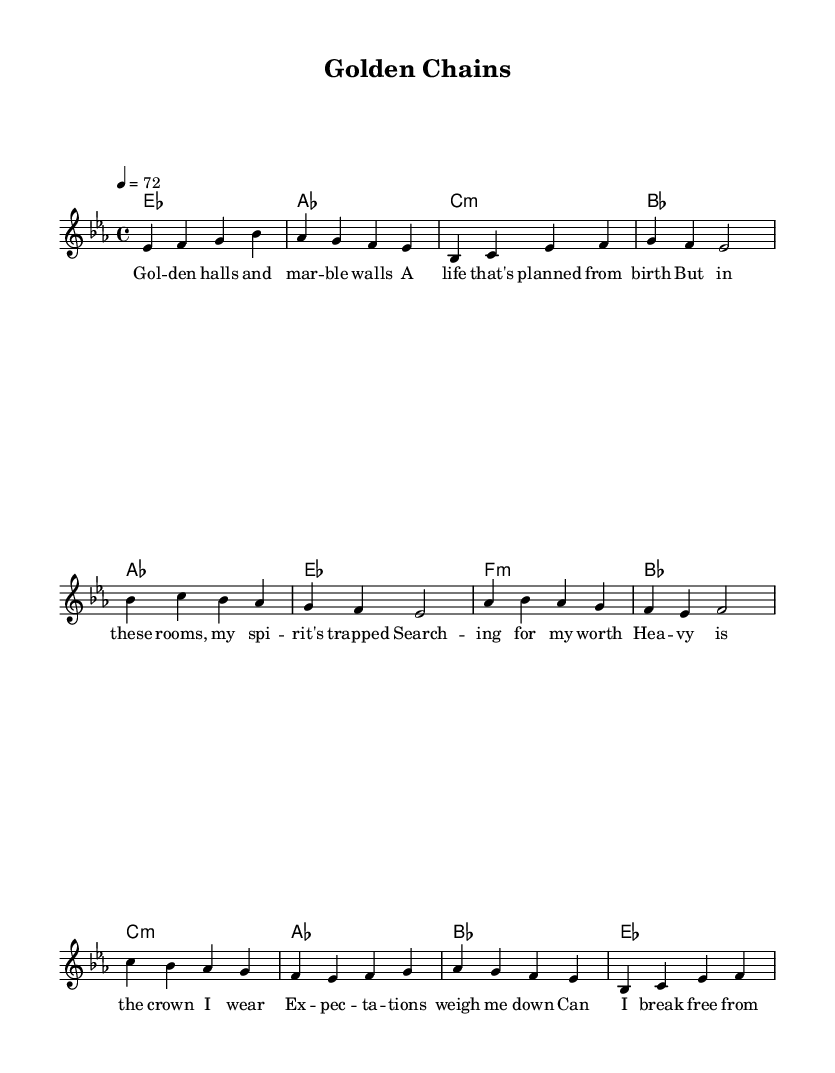What is the key signature of this music? The key signature is E flat major, which has three flat notes: B flat, E flat, and A flat.
Answer: E flat major What is the time signature of this sheet music? The time signature is indicated right after the key signature, which shows that there are four beats per measure, typical for pop music.
Answer: 4/4 What is the tempo marking for this piece? The tempo marking shows a speed of 72 beats per minute, which indicates a moderate pace for the ballad style.
Answer: 72 How many verses are in this piece? By examining the structure, I can see that it has one verse followed by a chorus, then a bridge, meaning there is one verse section presented.
Answer: One What main theme is explored in the lyrics? The lyrics talk about the pressures and expectations tied to family legacy, as seen in phrases that refer to wealth and searching for personal identity.
Answer: Family legacy What chords are used in the bridge section? The bridge section consists of three chords: C minor, A flat major, and B flat major; this can be determined by looking at the chord symbols written above the staff during that section.
Answer: C minor, A flat major, B flat major What does the chorus convey about personal feelings? The chorus expresses a sense of burden from expectations and a desire to break free from the constraints of family legacy, as directly stated in the lyrics.
Answer: Burden from expectations 